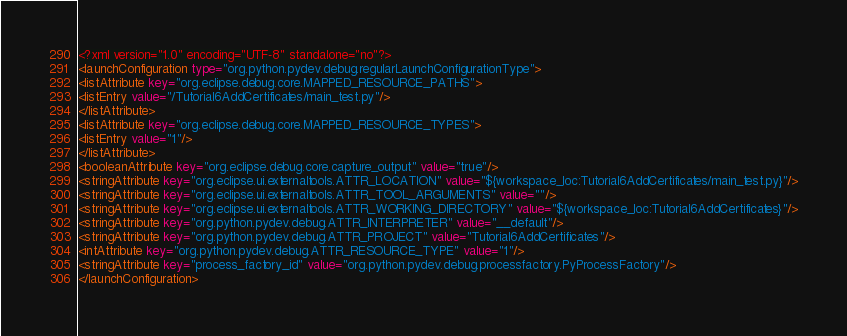Convert code to text. <code><loc_0><loc_0><loc_500><loc_500><_XML_><?xml version="1.0" encoding="UTF-8" standalone="no"?>
<launchConfiguration type="org.python.pydev.debug.regularLaunchConfigurationType">
<listAttribute key="org.eclipse.debug.core.MAPPED_RESOURCE_PATHS">
<listEntry value="/Tutorial6AddCertificates/main_test.py"/>
</listAttribute>
<listAttribute key="org.eclipse.debug.core.MAPPED_RESOURCE_TYPES">
<listEntry value="1"/>
</listAttribute>
<booleanAttribute key="org.eclipse.debug.core.capture_output" value="true"/>
<stringAttribute key="org.eclipse.ui.externaltools.ATTR_LOCATION" value="${workspace_loc:Tutorial6AddCertificates/main_test.py}"/>
<stringAttribute key="org.eclipse.ui.externaltools.ATTR_TOOL_ARGUMENTS" value=""/>
<stringAttribute key="org.eclipse.ui.externaltools.ATTR_WORKING_DIRECTORY" value="${workspace_loc:Tutorial6AddCertificates}"/>
<stringAttribute key="org.python.pydev.debug.ATTR_INTERPRETER" value="__default"/>
<stringAttribute key="org.python.pydev.debug.ATTR_PROJECT" value="Tutorial6AddCertificates"/>
<intAttribute key="org.python.pydev.debug.ATTR_RESOURCE_TYPE" value="1"/>
<stringAttribute key="process_factory_id" value="org.python.pydev.debug.processfactory.PyProcessFactory"/>
</launchConfiguration>
</code> 